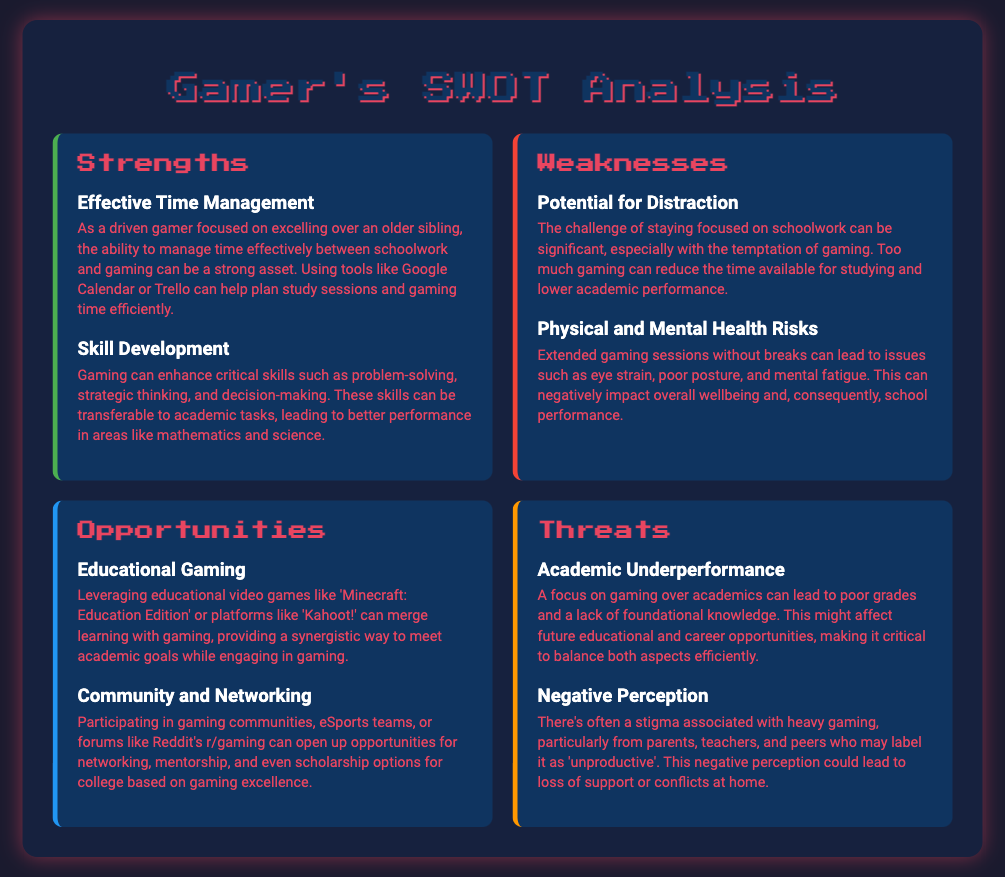What are the titles of the sections in the SWOT analysis? The sections in the SWOT analysis are Strengths, Weaknesses, Opportunities, and Threats.
Answer: Strengths, Weaknesses, Opportunities, Threats What is one strength mentioned in the analysis? The analysis lists Effective Time Management as one strength.
Answer: Effective Time Management What can extended gaming sessions lead to? The document mentions that extended gaming sessions can lead to physical and mental health risks.
Answer: Physical and Mental Health Risks Which educational game is referenced in the opportunities section? 'Minecraft: Education Edition' is an example given in the educational gaming opportunity.
Answer: Minecraft: Education Edition What is one potential threat of focusing too much on gaming? The analysis states that a focus on gaming can lead to academic underperformance.
Answer: Academic Underperformance What does the negative perception of gaming potentially affect? It could lead to a loss of support due to the stigma associated with heavy gaming.
Answer: Loss of support How does gaming help develop critical skills? Gaming enhances problem-solving, strategic thinking, and decision-making skills applicable in academics.
Answer: Problem-solving, strategic thinking, decision-making What tool is suggested for effective time management? Google Calendar or Trello are suggested tools for managing time between school and gaming.
Answer: Google Calendar or Trello 